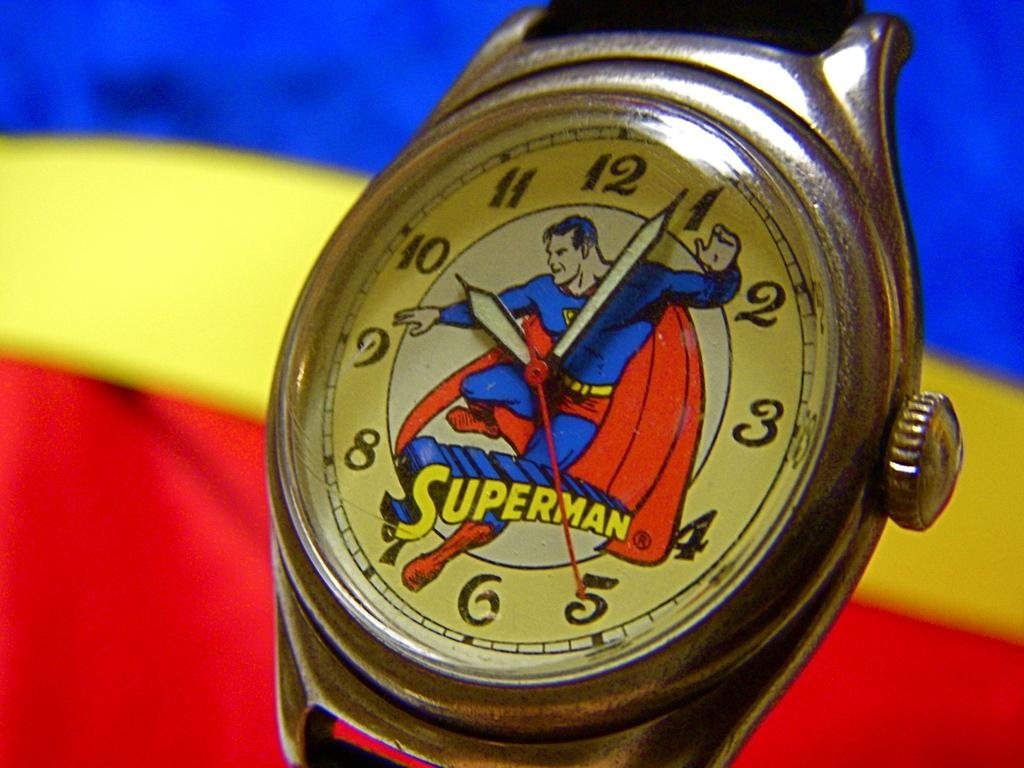<image>
Give a short and clear explanation of the subsequent image. A superman watch shows the time of a little after 10. 